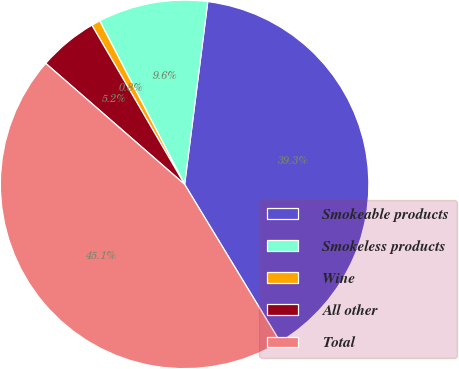<chart> <loc_0><loc_0><loc_500><loc_500><pie_chart><fcel>Smokeable products<fcel>Smokeless products<fcel>Wine<fcel>All other<fcel>Total<nl><fcel>39.32%<fcel>9.63%<fcel>0.77%<fcel>5.2%<fcel>45.09%<nl></chart> 